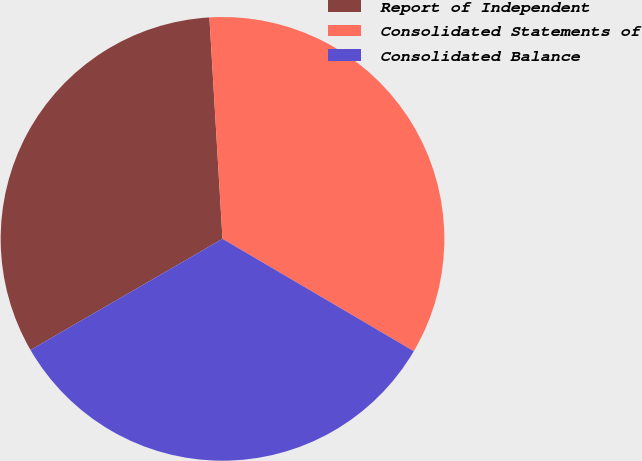<chart> <loc_0><loc_0><loc_500><loc_500><pie_chart><fcel>Report of Independent<fcel>Consolidated Statements of<fcel>Consolidated Balance<nl><fcel>32.41%<fcel>34.39%<fcel>33.2%<nl></chart> 